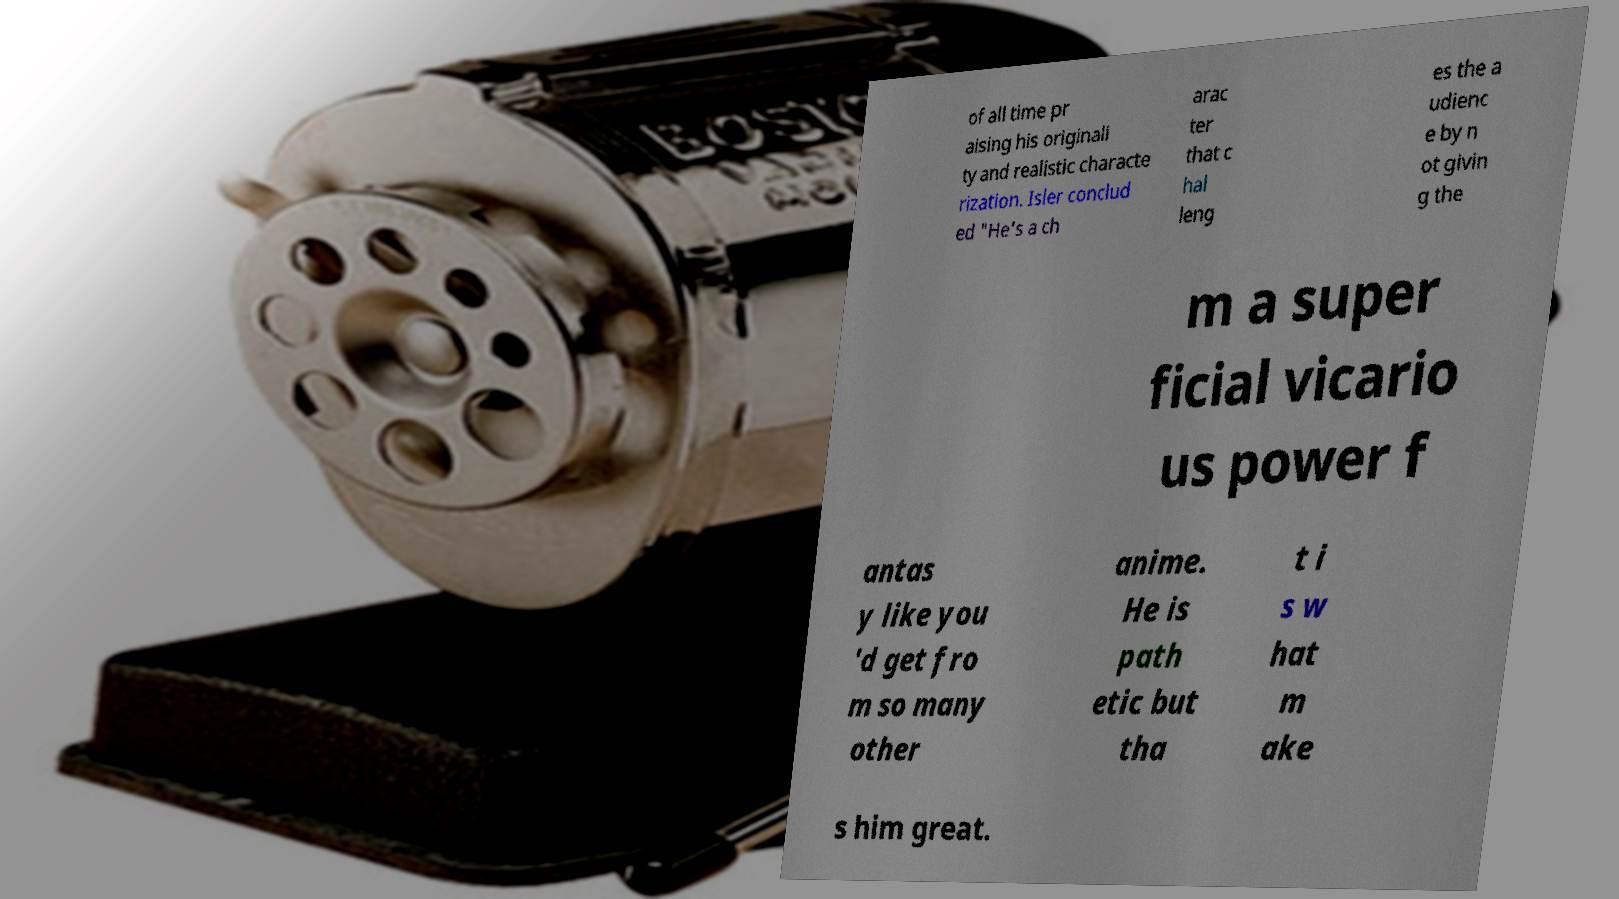Please identify and transcribe the text found in this image. of all time pr aising his originali ty and realistic characte rization. Isler conclud ed "He's a ch arac ter that c hal leng es the a udienc e by n ot givin g the m a super ficial vicario us power f antas y like you 'd get fro m so many other anime. He is path etic but tha t i s w hat m ake s him great. 